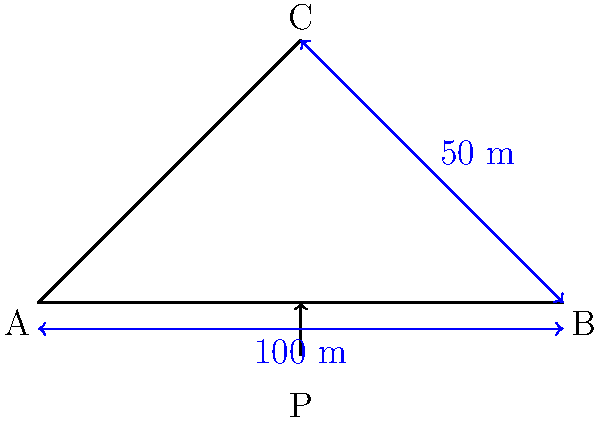A simple truss bridge is designed as shown in the figure. The bridge span is 100 m, and the truss height at the center is 50 m. A point load P is applied at the center of the bottom chord. If the maximum allowable stress in any member is 250 MPa and the cross-sectional area of each member is 0.1 m², what is the maximum load P that the bridge can safely support? To solve this problem, we'll follow these steps:

1. Determine the reactions at the supports:
   Due to symmetry, $R_A = R_B = P/2$

2. Calculate the forces in the members:
   For the vertical member: $F_{vertical} = P/2$
   For the diagonal members: $F_{diagonal} = \frac{P}{2} \cdot \frac{\sqrt{100^2 + 50^2}}{50} = 1.118P$

3. Find the maximum force:
   The maximum force occurs in the diagonal members: $F_{max} = 1.118P$

4. Use the stress formula to find the maximum load:
   $\sigma = F/A$, where $\sigma$ is the allowable stress, $F$ is the force, and $A$ is the cross-sectional area.

   $250 \times 10^6 = 1.118P / 0.1$

5. Solve for P:
   $P = (250 \times 10^6 \times 0.1) / 1.118 = 22.36 \times 10^6 N = 22.36 MN$

Therefore, the maximum load that the bridge can safely support is 22.36 MN.
Answer: 22.36 MN 